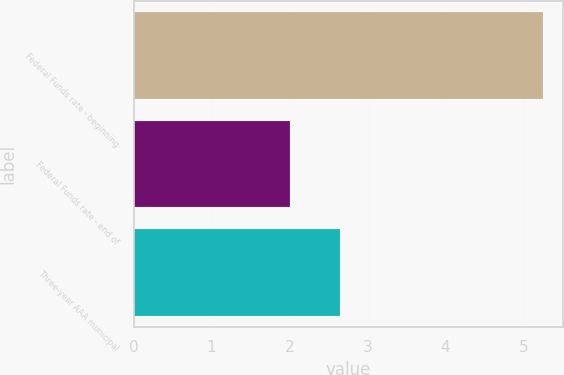<chart> <loc_0><loc_0><loc_500><loc_500><bar_chart><fcel>Federal Funds rate - beginning<fcel>Federal Funds rate - end of<fcel>Three-year AAA municipal<nl><fcel>5.25<fcel>2<fcel>2.65<nl></chart> 